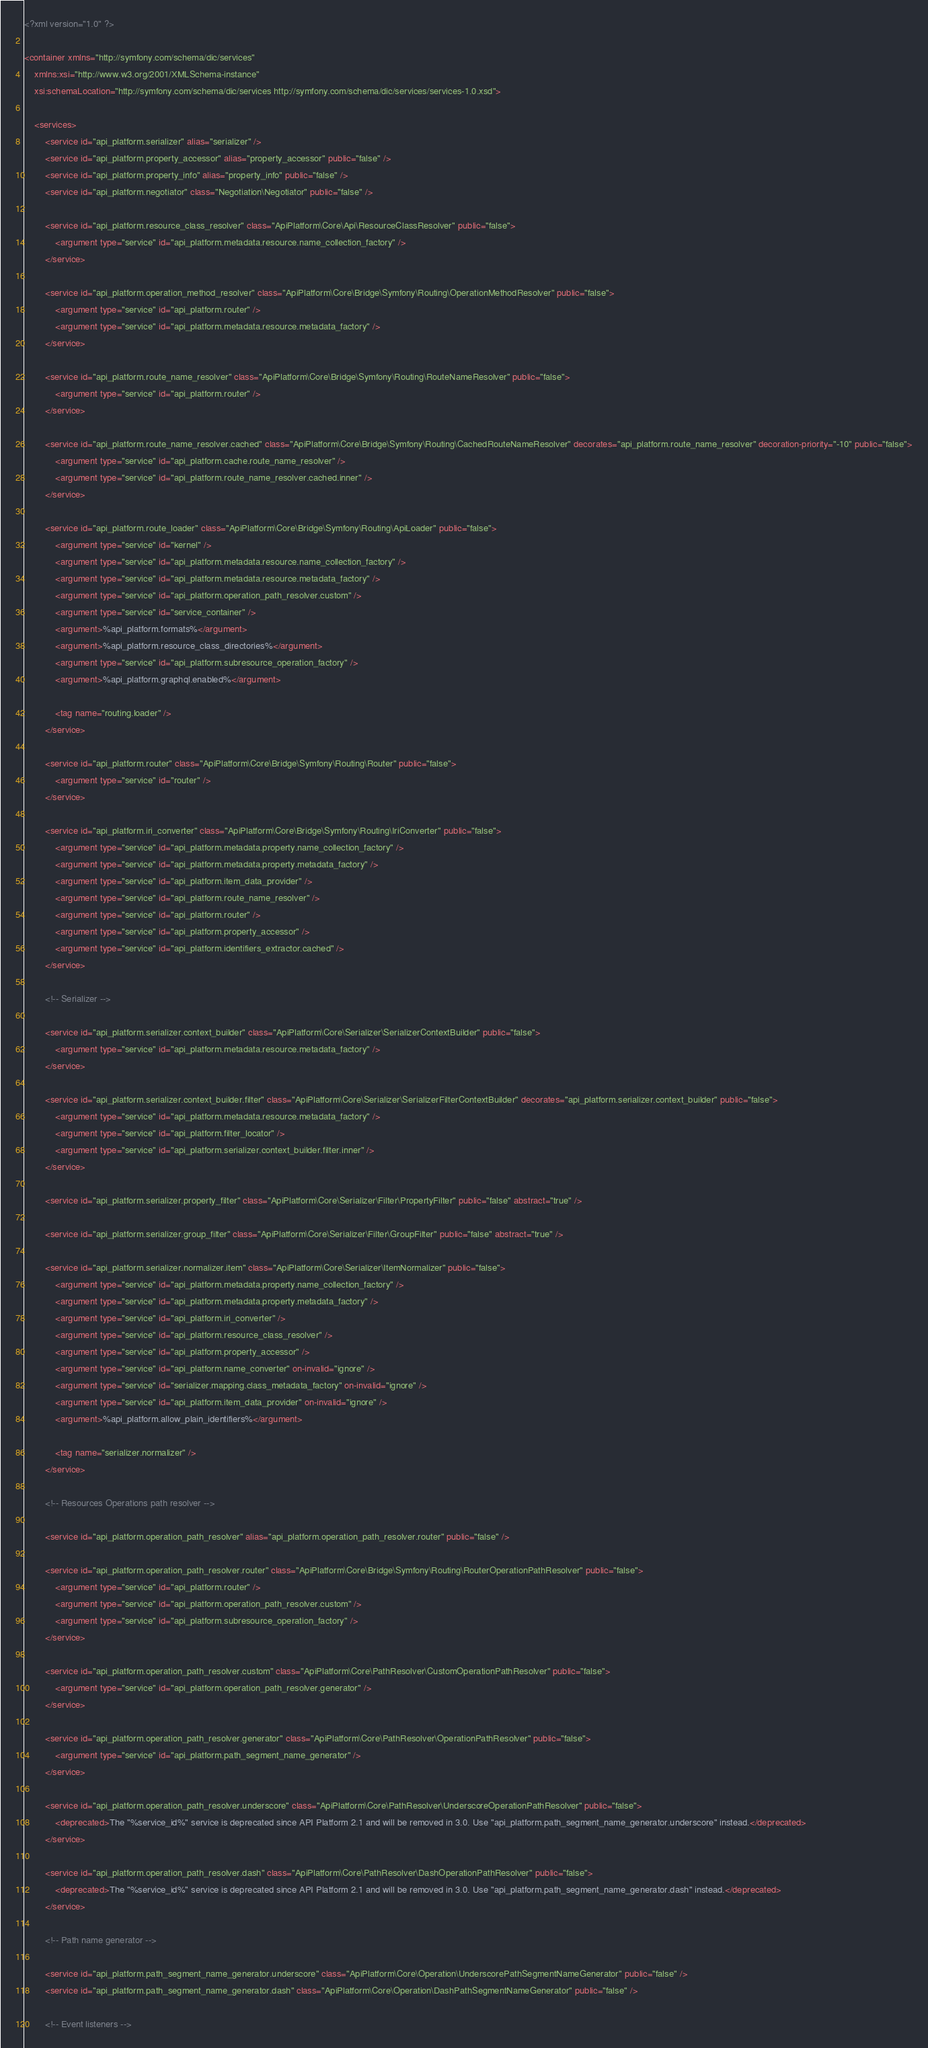Convert code to text. <code><loc_0><loc_0><loc_500><loc_500><_XML_><?xml version="1.0" ?>

<container xmlns="http://symfony.com/schema/dic/services"
    xmlns:xsi="http://www.w3.org/2001/XMLSchema-instance"
    xsi:schemaLocation="http://symfony.com/schema/dic/services http://symfony.com/schema/dic/services/services-1.0.xsd">

    <services>
        <service id="api_platform.serializer" alias="serializer" />
        <service id="api_platform.property_accessor" alias="property_accessor" public="false" />
        <service id="api_platform.property_info" alias="property_info" public="false" />
        <service id="api_platform.negotiator" class="Negotiation\Negotiator" public="false" />

        <service id="api_platform.resource_class_resolver" class="ApiPlatform\Core\Api\ResourceClassResolver" public="false">
            <argument type="service" id="api_platform.metadata.resource.name_collection_factory" />
        </service>

        <service id="api_platform.operation_method_resolver" class="ApiPlatform\Core\Bridge\Symfony\Routing\OperationMethodResolver" public="false">
            <argument type="service" id="api_platform.router" />
            <argument type="service" id="api_platform.metadata.resource.metadata_factory" />
        </service>

        <service id="api_platform.route_name_resolver" class="ApiPlatform\Core\Bridge\Symfony\Routing\RouteNameResolver" public="false">
            <argument type="service" id="api_platform.router" />
        </service>

        <service id="api_platform.route_name_resolver.cached" class="ApiPlatform\Core\Bridge\Symfony\Routing\CachedRouteNameResolver" decorates="api_platform.route_name_resolver" decoration-priority="-10" public="false">
            <argument type="service" id="api_platform.cache.route_name_resolver" />
            <argument type="service" id="api_platform.route_name_resolver.cached.inner" />
        </service>

        <service id="api_platform.route_loader" class="ApiPlatform\Core\Bridge\Symfony\Routing\ApiLoader" public="false">
            <argument type="service" id="kernel" />
            <argument type="service" id="api_platform.metadata.resource.name_collection_factory" />
            <argument type="service" id="api_platform.metadata.resource.metadata_factory" />
            <argument type="service" id="api_platform.operation_path_resolver.custom" />
            <argument type="service" id="service_container" />
            <argument>%api_platform.formats%</argument>
            <argument>%api_platform.resource_class_directories%</argument>
            <argument type="service" id="api_platform.subresource_operation_factory" />
            <argument>%api_platform.graphql.enabled%</argument>

            <tag name="routing.loader" />
        </service>

        <service id="api_platform.router" class="ApiPlatform\Core\Bridge\Symfony\Routing\Router" public="false">
            <argument type="service" id="router" />
        </service>

        <service id="api_platform.iri_converter" class="ApiPlatform\Core\Bridge\Symfony\Routing\IriConverter" public="false">
            <argument type="service" id="api_platform.metadata.property.name_collection_factory" />
            <argument type="service" id="api_platform.metadata.property.metadata_factory" />
            <argument type="service" id="api_platform.item_data_provider" />
            <argument type="service" id="api_platform.route_name_resolver" />
            <argument type="service" id="api_platform.router" />
            <argument type="service" id="api_platform.property_accessor" />
            <argument type="service" id="api_platform.identifiers_extractor.cached" />
        </service>

        <!-- Serializer -->

        <service id="api_platform.serializer.context_builder" class="ApiPlatform\Core\Serializer\SerializerContextBuilder" public="false">
            <argument type="service" id="api_platform.metadata.resource.metadata_factory" />
        </service>

        <service id="api_platform.serializer.context_builder.filter" class="ApiPlatform\Core\Serializer\SerializerFilterContextBuilder" decorates="api_platform.serializer.context_builder" public="false">
            <argument type="service" id="api_platform.metadata.resource.metadata_factory" />
            <argument type="service" id="api_platform.filter_locator" />
            <argument type="service" id="api_platform.serializer.context_builder.filter.inner" />
        </service>

        <service id="api_platform.serializer.property_filter" class="ApiPlatform\Core\Serializer\Filter\PropertyFilter" public="false" abstract="true" />

        <service id="api_platform.serializer.group_filter" class="ApiPlatform\Core\Serializer\Filter\GroupFilter" public="false" abstract="true" />

        <service id="api_platform.serializer.normalizer.item" class="ApiPlatform\Core\Serializer\ItemNormalizer" public="false">
            <argument type="service" id="api_platform.metadata.property.name_collection_factory" />
            <argument type="service" id="api_platform.metadata.property.metadata_factory" />
            <argument type="service" id="api_platform.iri_converter" />
            <argument type="service" id="api_platform.resource_class_resolver" />
            <argument type="service" id="api_platform.property_accessor" />
            <argument type="service" id="api_platform.name_converter" on-invalid="ignore" />
            <argument type="service" id="serializer.mapping.class_metadata_factory" on-invalid="ignore" />
            <argument type="service" id="api_platform.item_data_provider" on-invalid="ignore" />
            <argument>%api_platform.allow_plain_identifiers%</argument>

            <tag name="serializer.normalizer" />
        </service>

        <!-- Resources Operations path resolver -->

        <service id="api_platform.operation_path_resolver" alias="api_platform.operation_path_resolver.router" public="false" />

        <service id="api_platform.operation_path_resolver.router" class="ApiPlatform\Core\Bridge\Symfony\Routing\RouterOperationPathResolver" public="false">
            <argument type="service" id="api_platform.router" />
            <argument type="service" id="api_platform.operation_path_resolver.custom" />
            <argument type="service" id="api_platform.subresource_operation_factory" />
        </service>

        <service id="api_platform.operation_path_resolver.custom" class="ApiPlatform\Core\PathResolver\CustomOperationPathResolver" public="false">
            <argument type="service" id="api_platform.operation_path_resolver.generator" />
        </service>

        <service id="api_platform.operation_path_resolver.generator" class="ApiPlatform\Core\PathResolver\OperationPathResolver" public="false">
            <argument type="service" id="api_platform.path_segment_name_generator" />
        </service>

        <service id="api_platform.operation_path_resolver.underscore" class="ApiPlatform\Core\PathResolver\UnderscoreOperationPathResolver" public="false">
            <deprecated>The "%service_id%" service is deprecated since API Platform 2.1 and will be removed in 3.0. Use "api_platform.path_segment_name_generator.underscore" instead.</deprecated>
        </service>

        <service id="api_platform.operation_path_resolver.dash" class="ApiPlatform\Core\PathResolver\DashOperationPathResolver" public="false">
            <deprecated>The "%service_id%" service is deprecated since API Platform 2.1 and will be removed in 3.0. Use "api_platform.path_segment_name_generator.dash" instead.</deprecated>
        </service>

        <!-- Path name generator -->

        <service id="api_platform.path_segment_name_generator.underscore" class="ApiPlatform\Core\Operation\UnderscorePathSegmentNameGenerator" public="false" />
        <service id="api_platform.path_segment_name_generator.dash" class="ApiPlatform\Core\Operation\DashPathSegmentNameGenerator" public="false" />

        <!-- Event listeners -->
</code> 